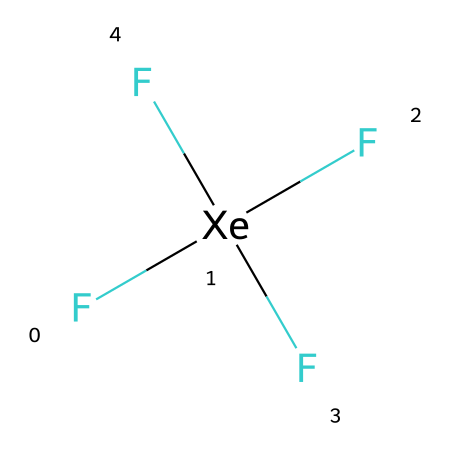What is the central atom in this compound? The central atom is identified by its position in the molecular structure. In xenon tetrafluoride, xenon (Xe) is at the center of the molecule with fluorine atoms surrounding it.
Answer: xenon How many fluorine atoms are bonded to xenon? By examining the structure, we see that there are four fluorine atoms (F) bonded to the central xenon atom (Xe). Hence, the total count is four.
Answer: four What is the molecular geometry of xenon tetrafluoride? To deduce the molecular geometry, we consider the number of bonded and lone pairs around the xenon atom. Xenon tetrafluoride has four bonded pairs and no lone pairs, leading to a square planar shape.
Answer: square planar Is xenon tetrafluoride a stable compound? The presence of a noble gas (xenon) bonded to highly electronegative fluorine atoms typically suggests that the compound is stable under certain conditions. Generally, xenon tetrafluoride is stable, though it may decompose under extreme conditions.
Answer: yes What type of compound is xenon tetrafluoride classified as? This compound contains a noble gas (xenon) with more than an octet of electrons, specifically four bonding electron pairs, thus classifying it as a hypervalent compound.
Answer: hypervalent What hybridization does the central atom exhibit in xenon tetrafluoride? The central xenon atom in the compound forms four equivalent bonds with the fluorine atoms, denoting sp3d hybridization. This assignment can be derived from the geometry and bonding configuration.
Answer: sp3d What is the oxidation state of xenon in xenon tetrafluoride? To find the oxidation state, we assign oxidation states to the fluorine atoms first (each being -1) and then solve for xenon. Thus, with four fluorines contributing -4, xenon balances this with an oxidation state of +4.
Answer: +4 